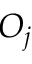Convert formula to latex. <formula><loc_0><loc_0><loc_500><loc_500>O _ { j }</formula> 